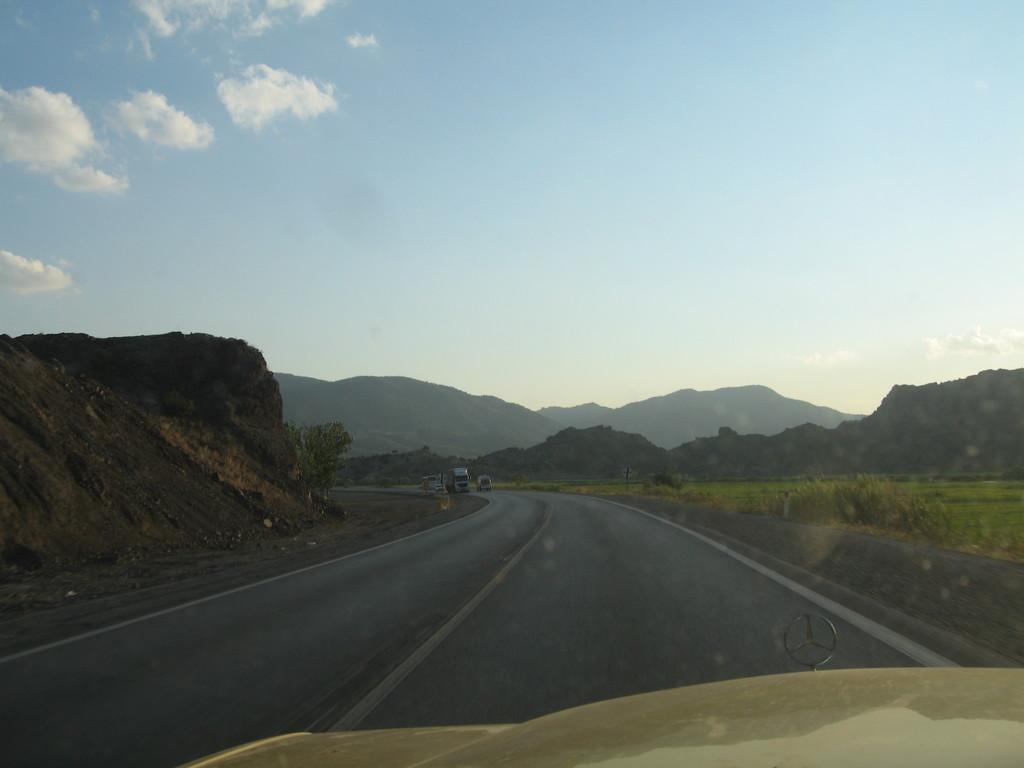Please provide a concise description of this image. The image is taken from a vehicle. In the foreground of the picture it is road. On the right there are hills, fields and soil. on the left it is hill. In the middle of the picture there are trees and hills. At the top it is sky. 